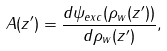Convert formula to latex. <formula><loc_0><loc_0><loc_500><loc_500>A ( z ^ { \prime } ) = \frac { d \psi _ { e x c } ( \rho _ { w } ( z ^ { \prime } ) ) } { d \rho _ { w } ( z ^ { \prime } ) } ,</formula> 